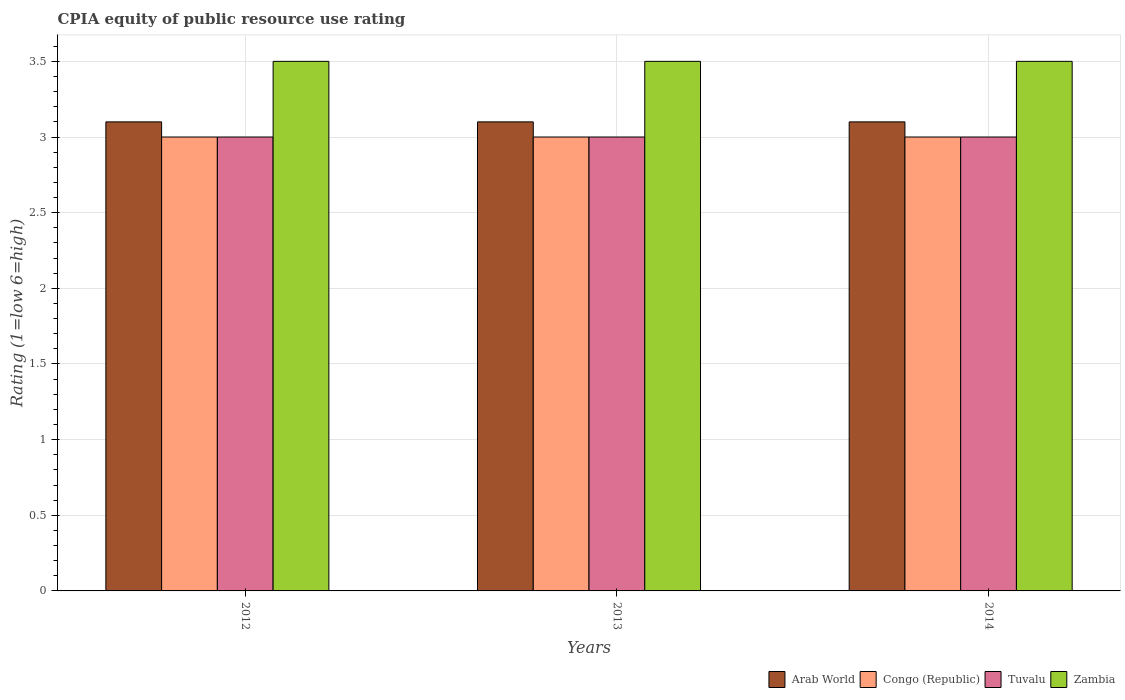Are the number of bars per tick equal to the number of legend labels?
Give a very brief answer. Yes. Are the number of bars on each tick of the X-axis equal?
Offer a terse response. Yes. How many bars are there on the 2nd tick from the left?
Make the answer very short. 4. How many bars are there on the 2nd tick from the right?
Your response must be concise. 4. What is the label of the 1st group of bars from the left?
Your response must be concise. 2012. What is the CPIA rating in Zambia in 2014?
Make the answer very short. 3.5. Across all years, what is the maximum CPIA rating in Zambia?
Offer a very short reply. 3.5. Across all years, what is the minimum CPIA rating in Zambia?
Provide a short and direct response. 3.5. In which year was the CPIA rating in Zambia maximum?
Provide a succinct answer. 2012. In which year was the CPIA rating in Congo (Republic) minimum?
Ensure brevity in your answer.  2012. What is the total CPIA rating in Congo (Republic) in the graph?
Ensure brevity in your answer.  9. What is the difference between the CPIA rating in Congo (Republic) in 2014 and the CPIA rating in Arab World in 2013?
Provide a short and direct response. -0.1. What is the average CPIA rating in Congo (Republic) per year?
Your response must be concise. 3. In the year 2012, what is the difference between the CPIA rating in Congo (Republic) and CPIA rating in Tuvalu?
Provide a short and direct response. 0. What is the ratio of the CPIA rating in Tuvalu in 2013 to that in 2014?
Your answer should be compact. 1. Is the CPIA rating in Zambia in 2013 less than that in 2014?
Ensure brevity in your answer.  No. Is the difference between the CPIA rating in Congo (Republic) in 2013 and 2014 greater than the difference between the CPIA rating in Tuvalu in 2013 and 2014?
Ensure brevity in your answer.  No. What is the difference between the highest and the second highest CPIA rating in Zambia?
Give a very brief answer. 0. Is it the case that in every year, the sum of the CPIA rating in Tuvalu and CPIA rating in Arab World is greater than the sum of CPIA rating in Congo (Republic) and CPIA rating in Zambia?
Provide a short and direct response. Yes. What does the 1st bar from the left in 2014 represents?
Offer a terse response. Arab World. What does the 1st bar from the right in 2013 represents?
Give a very brief answer. Zambia. Is it the case that in every year, the sum of the CPIA rating in Tuvalu and CPIA rating in Arab World is greater than the CPIA rating in Congo (Republic)?
Give a very brief answer. Yes. How many years are there in the graph?
Keep it short and to the point. 3. Are the values on the major ticks of Y-axis written in scientific E-notation?
Your response must be concise. No. Does the graph contain any zero values?
Keep it short and to the point. No. Does the graph contain grids?
Offer a terse response. Yes. Where does the legend appear in the graph?
Provide a succinct answer. Bottom right. How many legend labels are there?
Your answer should be compact. 4. How are the legend labels stacked?
Offer a very short reply. Horizontal. What is the title of the graph?
Provide a succinct answer. CPIA equity of public resource use rating. Does "United Arab Emirates" appear as one of the legend labels in the graph?
Make the answer very short. No. What is the Rating (1=low 6=high) of Tuvalu in 2012?
Ensure brevity in your answer.  3. What is the Rating (1=low 6=high) in Zambia in 2012?
Make the answer very short. 3.5. What is the Rating (1=low 6=high) in Arab World in 2013?
Your answer should be compact. 3.1. What is the Rating (1=low 6=high) of Congo (Republic) in 2013?
Your answer should be very brief. 3. What is the Rating (1=low 6=high) of Tuvalu in 2013?
Ensure brevity in your answer.  3. What is the Rating (1=low 6=high) of Arab World in 2014?
Your answer should be very brief. 3.1. What is the Rating (1=low 6=high) in Tuvalu in 2014?
Provide a short and direct response. 3. What is the Rating (1=low 6=high) in Zambia in 2014?
Your response must be concise. 3.5. Across all years, what is the maximum Rating (1=low 6=high) of Congo (Republic)?
Provide a short and direct response. 3. Across all years, what is the maximum Rating (1=low 6=high) of Tuvalu?
Your answer should be compact. 3. Across all years, what is the maximum Rating (1=low 6=high) in Zambia?
Your answer should be compact. 3.5. Across all years, what is the minimum Rating (1=low 6=high) in Congo (Republic)?
Your response must be concise. 3. Across all years, what is the minimum Rating (1=low 6=high) in Tuvalu?
Your answer should be very brief. 3. Across all years, what is the minimum Rating (1=low 6=high) in Zambia?
Ensure brevity in your answer.  3.5. What is the total Rating (1=low 6=high) of Congo (Republic) in the graph?
Your answer should be compact. 9. What is the total Rating (1=low 6=high) of Tuvalu in the graph?
Provide a succinct answer. 9. What is the difference between the Rating (1=low 6=high) in Arab World in 2012 and that in 2013?
Your response must be concise. 0. What is the difference between the Rating (1=low 6=high) in Tuvalu in 2012 and that in 2014?
Your response must be concise. 0. What is the difference between the Rating (1=low 6=high) in Zambia in 2012 and that in 2014?
Provide a short and direct response. 0. What is the difference between the Rating (1=low 6=high) in Tuvalu in 2013 and that in 2014?
Your answer should be compact. 0. What is the difference between the Rating (1=low 6=high) in Zambia in 2013 and that in 2014?
Provide a short and direct response. 0. What is the difference between the Rating (1=low 6=high) of Arab World in 2012 and the Rating (1=low 6=high) of Tuvalu in 2013?
Provide a short and direct response. 0.1. What is the difference between the Rating (1=low 6=high) of Congo (Republic) in 2012 and the Rating (1=low 6=high) of Tuvalu in 2013?
Your response must be concise. 0. What is the difference between the Rating (1=low 6=high) in Tuvalu in 2012 and the Rating (1=low 6=high) in Zambia in 2013?
Make the answer very short. -0.5. What is the difference between the Rating (1=low 6=high) of Arab World in 2012 and the Rating (1=low 6=high) of Congo (Republic) in 2014?
Keep it short and to the point. 0.1. What is the difference between the Rating (1=low 6=high) in Congo (Republic) in 2012 and the Rating (1=low 6=high) in Zambia in 2014?
Offer a terse response. -0.5. What is the difference between the Rating (1=low 6=high) in Tuvalu in 2012 and the Rating (1=low 6=high) in Zambia in 2014?
Keep it short and to the point. -0.5. What is the difference between the Rating (1=low 6=high) of Arab World in 2013 and the Rating (1=low 6=high) of Congo (Republic) in 2014?
Your answer should be very brief. 0.1. What is the difference between the Rating (1=low 6=high) of Congo (Republic) in 2013 and the Rating (1=low 6=high) of Tuvalu in 2014?
Ensure brevity in your answer.  0. What is the difference between the Rating (1=low 6=high) of Congo (Republic) in 2013 and the Rating (1=low 6=high) of Zambia in 2014?
Make the answer very short. -0.5. What is the average Rating (1=low 6=high) of Congo (Republic) per year?
Your answer should be compact. 3. What is the average Rating (1=low 6=high) in Zambia per year?
Make the answer very short. 3.5. In the year 2012, what is the difference between the Rating (1=low 6=high) of Arab World and Rating (1=low 6=high) of Tuvalu?
Provide a succinct answer. 0.1. In the year 2012, what is the difference between the Rating (1=low 6=high) in Arab World and Rating (1=low 6=high) in Zambia?
Your response must be concise. -0.4. In the year 2012, what is the difference between the Rating (1=low 6=high) in Congo (Republic) and Rating (1=low 6=high) in Tuvalu?
Offer a very short reply. 0. In the year 2012, what is the difference between the Rating (1=low 6=high) in Congo (Republic) and Rating (1=low 6=high) in Zambia?
Give a very brief answer. -0.5. In the year 2012, what is the difference between the Rating (1=low 6=high) in Tuvalu and Rating (1=low 6=high) in Zambia?
Keep it short and to the point. -0.5. In the year 2013, what is the difference between the Rating (1=low 6=high) of Arab World and Rating (1=low 6=high) of Congo (Republic)?
Give a very brief answer. 0.1. In the year 2013, what is the difference between the Rating (1=low 6=high) of Arab World and Rating (1=low 6=high) of Tuvalu?
Your response must be concise. 0.1. In the year 2013, what is the difference between the Rating (1=low 6=high) in Congo (Republic) and Rating (1=low 6=high) in Tuvalu?
Provide a short and direct response. 0. In the year 2013, what is the difference between the Rating (1=low 6=high) in Congo (Republic) and Rating (1=low 6=high) in Zambia?
Ensure brevity in your answer.  -0.5. In the year 2014, what is the difference between the Rating (1=low 6=high) of Arab World and Rating (1=low 6=high) of Congo (Republic)?
Provide a short and direct response. 0.1. In the year 2014, what is the difference between the Rating (1=low 6=high) in Arab World and Rating (1=low 6=high) in Tuvalu?
Provide a succinct answer. 0.1. In the year 2014, what is the difference between the Rating (1=low 6=high) in Congo (Republic) and Rating (1=low 6=high) in Tuvalu?
Provide a short and direct response. 0. In the year 2014, what is the difference between the Rating (1=low 6=high) of Tuvalu and Rating (1=low 6=high) of Zambia?
Offer a terse response. -0.5. What is the ratio of the Rating (1=low 6=high) of Arab World in 2012 to that in 2013?
Your answer should be compact. 1. What is the ratio of the Rating (1=low 6=high) in Congo (Republic) in 2012 to that in 2013?
Your response must be concise. 1. What is the ratio of the Rating (1=low 6=high) in Tuvalu in 2012 to that in 2013?
Your response must be concise. 1. What is the ratio of the Rating (1=low 6=high) of Congo (Republic) in 2012 to that in 2014?
Give a very brief answer. 1. What is the ratio of the Rating (1=low 6=high) of Tuvalu in 2012 to that in 2014?
Keep it short and to the point. 1. What is the ratio of the Rating (1=low 6=high) of Zambia in 2012 to that in 2014?
Keep it short and to the point. 1. What is the ratio of the Rating (1=low 6=high) of Arab World in 2013 to that in 2014?
Your answer should be very brief. 1. What is the ratio of the Rating (1=low 6=high) of Zambia in 2013 to that in 2014?
Provide a succinct answer. 1. What is the difference between the highest and the second highest Rating (1=low 6=high) in Congo (Republic)?
Provide a succinct answer. 0. What is the difference between the highest and the second highest Rating (1=low 6=high) of Tuvalu?
Provide a succinct answer. 0. What is the difference between the highest and the second highest Rating (1=low 6=high) in Zambia?
Provide a succinct answer. 0. What is the difference between the highest and the lowest Rating (1=low 6=high) in Arab World?
Provide a succinct answer. 0. What is the difference between the highest and the lowest Rating (1=low 6=high) in Zambia?
Keep it short and to the point. 0. 